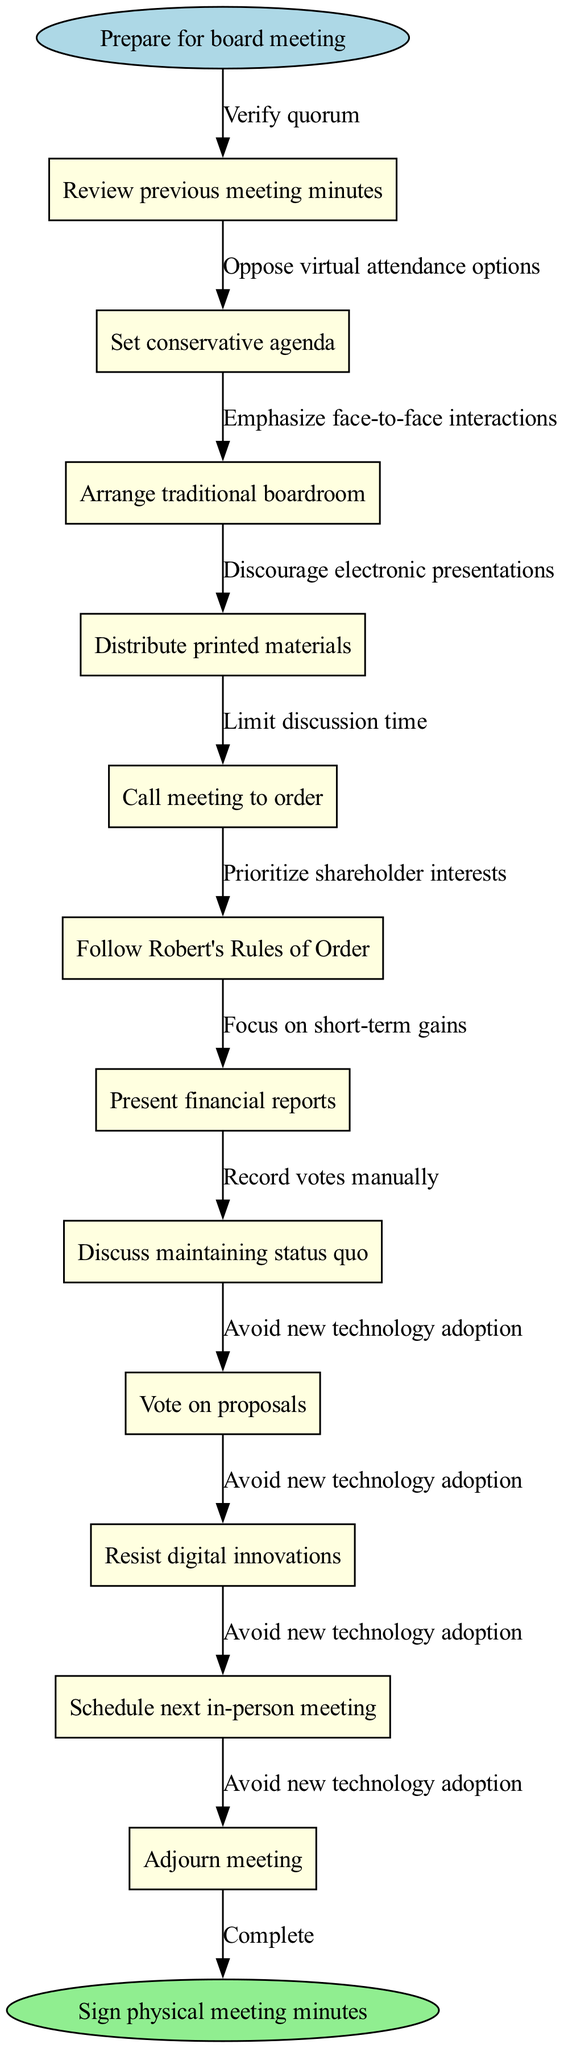What is the starting node of the flowchart? The starting node of the flowchart is labeled "Prepare for board meeting." This is identified as the first node in the diagram that signifies the beginning of the process.
Answer: Prepare for board meeting How many nodes are present in the flowchart? By counting each listed node within the diagram, a total of eleven nodes can be identified, including the start and end nodes.
Answer: 11 What is the last action in the flowchart? The final action represented in the flowchart is "Sign physical meeting minutes," which is shown as the end node. This follows all the previous process steps.
Answer: Sign physical meeting minutes Which node follows "Present financial reports"? After "Present financial reports," the next node in the flowchart is "Discuss maintaining status quo." This is determined by the sequential flow indicated in the diagram.
Answer: Discuss maintaining status quo What is the relationship between "Vote on proposals" and "Resist digital innovations"? The relationship shows that after "Vote on proposals," the next step is to "Resist digital innovations," indicating this is a subsequent action directly connected by the flow of the process.
Answer: Resist digital innovations How many edges are used in this flowchart? The flowchart has ten edges, which connect the various nodes and help to visualize the flow of the meeting process from start to finish.
Answer: 10 What does the edge from "Call meeting to order" signify? The edge from "Call meeting to order" signifies the transition to the next node, which is "Follow Robert's Rules of Order," indicating that a structured approach will follow after the meeting begins.
Answer: Follow Robert's Rules of Order Which node emphasizes maintaining traditional practices? The node "Resist digital innovations" emphasizes maintaining traditional practices as it reflects a resistance to changing the conventional methods of board meetings.
Answer: Resist digital innovations What is the purpose of the edge labeled "Verify quorum"? The edge labeled "Verify quorum" connects the starting action to "Review previous meeting minutes," indicating the necessity to confirm the adequate number of board members before proceeding.
Answer: Review previous meeting minutes 